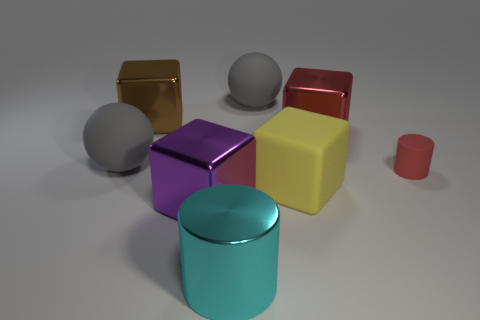How many red things are metallic cylinders or small rubber things?
Offer a terse response. 1. Do the metallic cylinder and the big rubber object that is in front of the tiny matte cylinder have the same color?
Keep it short and to the point. No. How many other objects are there of the same color as the big cylinder?
Provide a succinct answer. 0. Are there fewer big purple things than large cubes?
Provide a short and direct response. Yes. How many balls are left of the gray object that is behind the ball that is to the left of the purple thing?
Keep it short and to the point. 1. There is a shiny cube right of the metal cylinder; what is its size?
Ensure brevity in your answer.  Large. There is a metallic thing right of the big yellow rubber block; is it the same shape as the yellow object?
Ensure brevity in your answer.  Yes. There is a brown thing that is the same shape as the large yellow object; what material is it?
Give a very brief answer. Metal. Are there any other things that have the same size as the yellow matte block?
Your response must be concise. Yes. Are there any small blue balls?
Make the answer very short. No. 